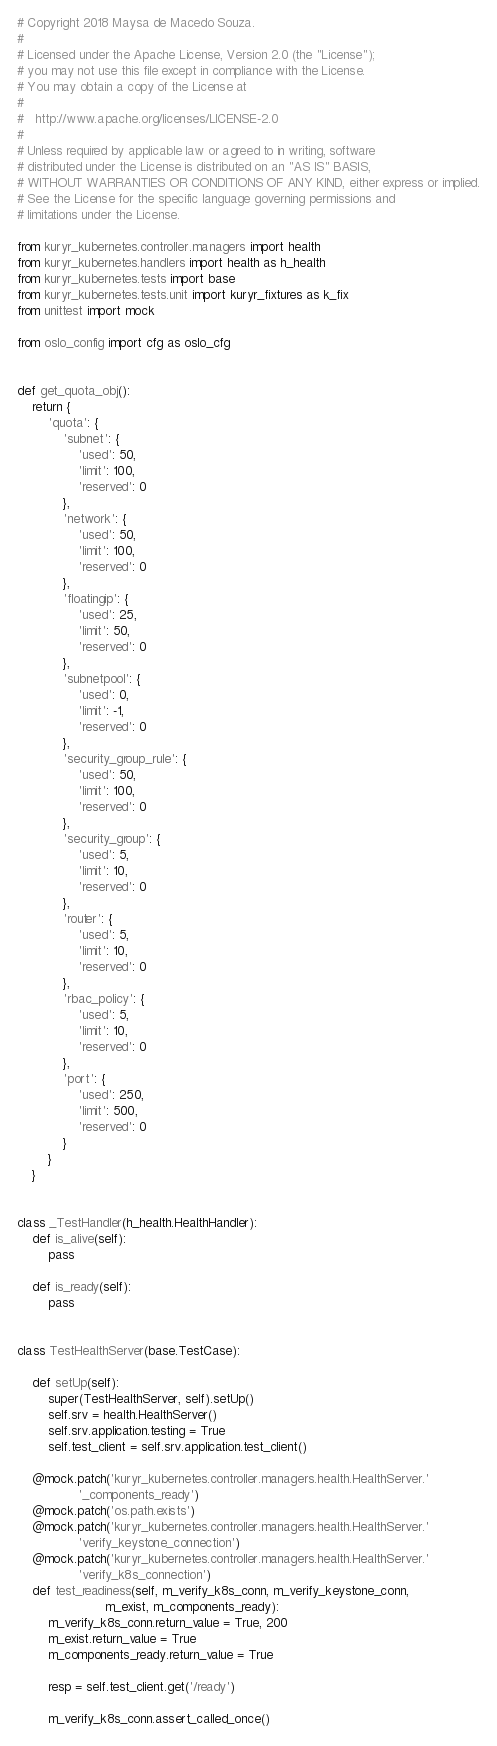Convert code to text. <code><loc_0><loc_0><loc_500><loc_500><_Python_># Copyright 2018 Maysa de Macedo Souza.
#
# Licensed under the Apache License, Version 2.0 (the "License");
# you may not use this file except in compliance with the License.
# You may obtain a copy of the License at
#
#   http://www.apache.org/licenses/LICENSE-2.0
#
# Unless required by applicable law or agreed to in writing, software
# distributed under the License is distributed on an "AS IS" BASIS,
# WITHOUT WARRANTIES OR CONDITIONS OF ANY KIND, either express or implied.
# See the License for the specific language governing permissions and
# limitations under the License.

from kuryr_kubernetes.controller.managers import health
from kuryr_kubernetes.handlers import health as h_health
from kuryr_kubernetes.tests import base
from kuryr_kubernetes.tests.unit import kuryr_fixtures as k_fix
from unittest import mock

from oslo_config import cfg as oslo_cfg


def get_quota_obj():
    return {
        'quota': {
            'subnet': {
                'used': 50,
                'limit': 100,
                'reserved': 0
            },
            'network': {
                'used': 50,
                'limit': 100,
                'reserved': 0
            },
            'floatingip': {
                'used': 25,
                'limit': 50,
                'reserved': 0
            },
            'subnetpool': {
                'used': 0,
                'limit': -1,
                'reserved': 0
            },
            'security_group_rule': {
                'used': 50,
                'limit': 100,
                'reserved': 0
            },
            'security_group': {
                'used': 5,
                'limit': 10,
                'reserved': 0
            },
            'router': {
                'used': 5,
                'limit': 10,
                'reserved': 0
            },
            'rbac_policy': {
                'used': 5,
                'limit': 10,
                'reserved': 0
            },
            'port': {
                'used': 250,
                'limit': 500,
                'reserved': 0
            }
        }
    }


class _TestHandler(h_health.HealthHandler):
    def is_alive(self):
        pass

    def is_ready(self):
        pass


class TestHealthServer(base.TestCase):

    def setUp(self):
        super(TestHealthServer, self).setUp()
        self.srv = health.HealthServer()
        self.srv.application.testing = True
        self.test_client = self.srv.application.test_client()

    @mock.patch('kuryr_kubernetes.controller.managers.health.HealthServer.'
                '_components_ready')
    @mock.patch('os.path.exists')
    @mock.patch('kuryr_kubernetes.controller.managers.health.HealthServer.'
                'verify_keystone_connection')
    @mock.patch('kuryr_kubernetes.controller.managers.health.HealthServer.'
                'verify_k8s_connection')
    def test_readiness(self, m_verify_k8s_conn, m_verify_keystone_conn,
                       m_exist, m_components_ready):
        m_verify_k8s_conn.return_value = True, 200
        m_exist.return_value = True
        m_components_ready.return_value = True

        resp = self.test_client.get('/ready')

        m_verify_k8s_conn.assert_called_once()</code> 